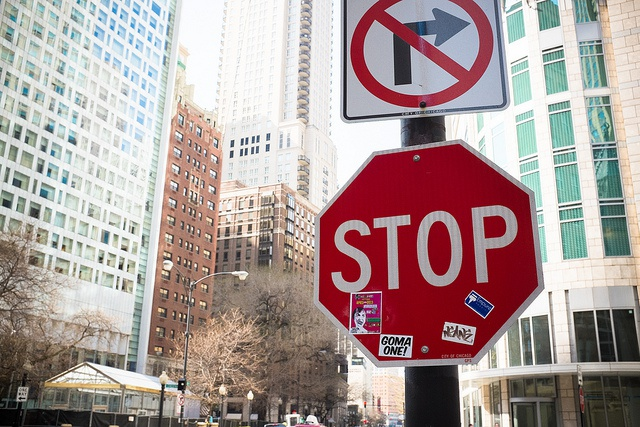Describe the objects in this image and their specific colors. I can see a stop sign in blue, maroon, darkgray, and lightgray tones in this image. 